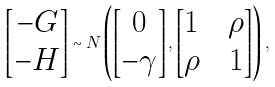<formula> <loc_0><loc_0><loc_500><loc_500>\left [ \begin{matrix} - G \\ - H \end{matrix} \right ] \sim N \left ( \left [ \begin{matrix} 0 \\ - \gamma \end{matrix} \right ] , \left [ \begin{matrix} 1 \quad \rho \\ \rho \quad 1 \end{matrix} \right ] \right ) ,</formula> 